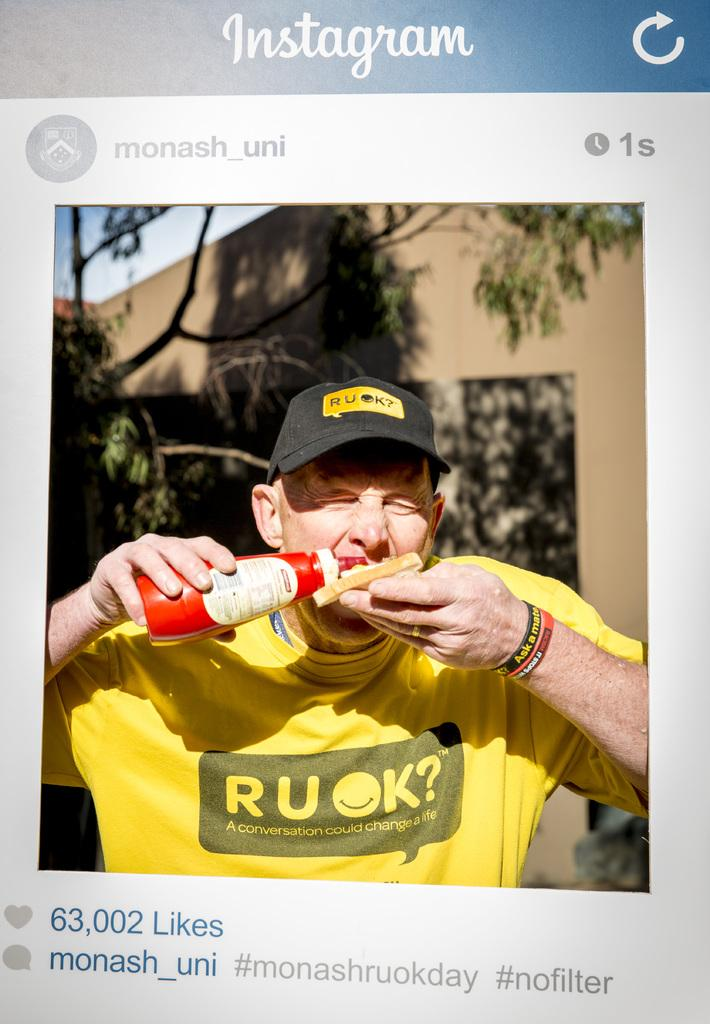Provide a one-sentence caption for the provided image. An Instagram post of a man eating and that was posted one second ago. 